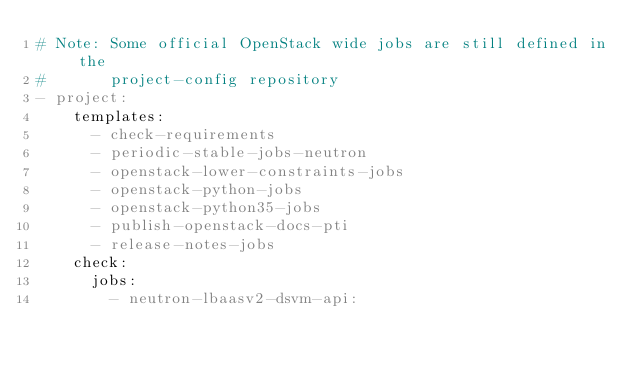<code> <loc_0><loc_0><loc_500><loc_500><_YAML_># Note: Some official OpenStack wide jobs are still defined in the
#       project-config repository
- project:
    templates:
      - check-requirements
      - periodic-stable-jobs-neutron
      - openstack-lower-constraints-jobs
      - openstack-python-jobs
      - openstack-python35-jobs
      - publish-openstack-docs-pti
      - release-notes-jobs
    check:
      jobs:
        - neutron-lbaasv2-dsvm-api:</code> 